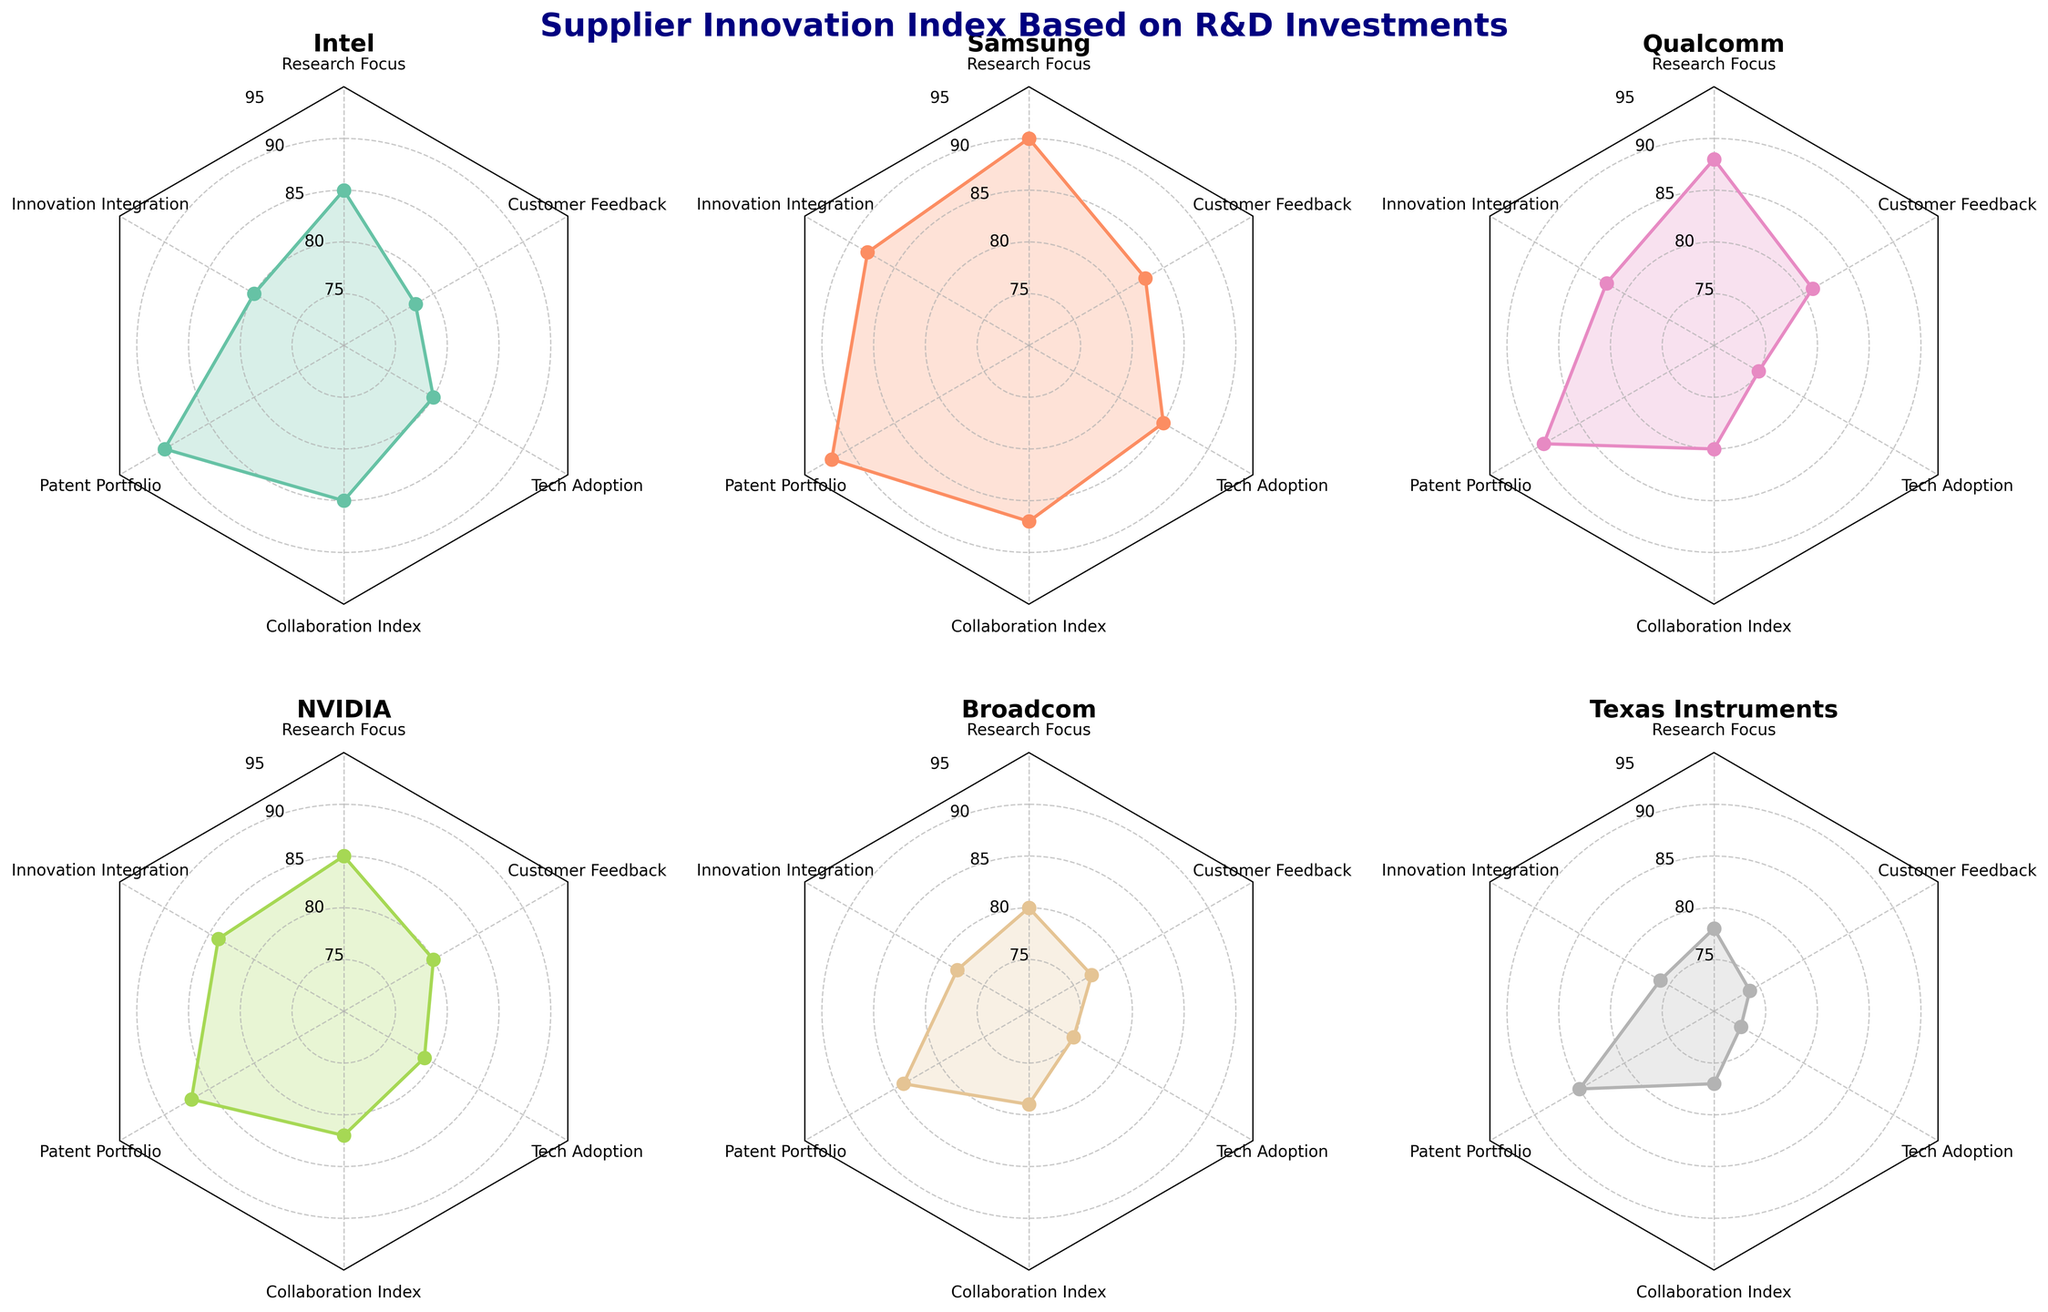Which supplier has the highest score in Patent Portfolio? By examining the radar plot subplots for each supplier, the highest value for the Patent Portfolio parameter appears to be visible. Comparing these values directly shows that Samsung holds the highest score of 92.
Answer: Samsung How does Texas Instruments compare to Qualcomm in Tech Adoption? First, locate the Tech Adoption values on the radar charts for Texas Instruments and Qualcomm. Texas Instruments has a score of 73, while Qualcomm has a score of 75. Thus, Qualcomm scores higher in Tech Adoption.
Answer: Qualcomm scores higher Which company appears to have the most balanced R&D investment across all parameters? A balanced R&D investment would mean the plotted radar shape is close to circular. Inspecting all the radar charts, Intel and Samsung show fairly even distributions across all categories, but Samsung has slightly higher uniformity in their scores.
Answer: Samsung What are the average scores for NVIDIA in Research Focus and Collaboration Index? To find the average, sum NVIDIA's scores in these two parameters: Research Focus (85) and Collaboration Index (82). Then divide by 2. Calculation: (85 + 82) / 2 = 83.5.
Answer: 83.5 Between Intel and Broadcom, which company has a higher score in Customer Feedback? Analyze the Customer Feedback scores on the radar plots of Intel and Broadcom. Intel has a score of 78, and Broadcom has a score of 77. Therefore, Intel scores higher in Customer Feedback.
Answer: Intel What is the range of scores for Samsung in all categories? Identify the highest and lowest scores in Samsung's radar chart: highest is for Patent Portfolio (92) and lowest is for Customer Feedback (83). Range is obtained by subtracting the lowest from the highest: 92 - 83 = 9.
Answer: 9 Which parameter has the lowest average score across all six companies? Calculate the average for each parameter: Research Focus, Innovation Integration, Patent Portfolio, Collaboration Index, Tech Adoption, Customer Feedback. Sum all values for each, then divide by six (number of companies). Customer Feedback has consistently lower scores, indicating it has the lowest average.
Answer: Customer Feedback Are there any two categories where Qualcomm scores identically? Assess Qualcomm's radar plot to identify if any two scores match. Both Innovation Integration and Patent Portfolio for Qualcomm are 89.
Answer: Yes, Innovation Integration and Patent Portfolio What is the maximum score difference in Collaboration Index between any two suppliers? Check the highest and lowest Collaboration Index scores among all suppliers: Samsung (87) and Texas Instruments (77). Subtract the lowest from the highest: 87 - 77 = 10.
Answer: 10 How does Broadcom's Innovation Integration score compare to the average Innovation Integration score across all companies? First, find Broadcom’s Innovation Integration score (78). Calculate the average Innovation Integration by summing all relevant scores and dividing by six. Average = (80 + 88 + 82 + 84 + 78 + 76) / 6 ≈ 81.33. Broadcom’s score of 78 is below the average.
Answer: Below average 